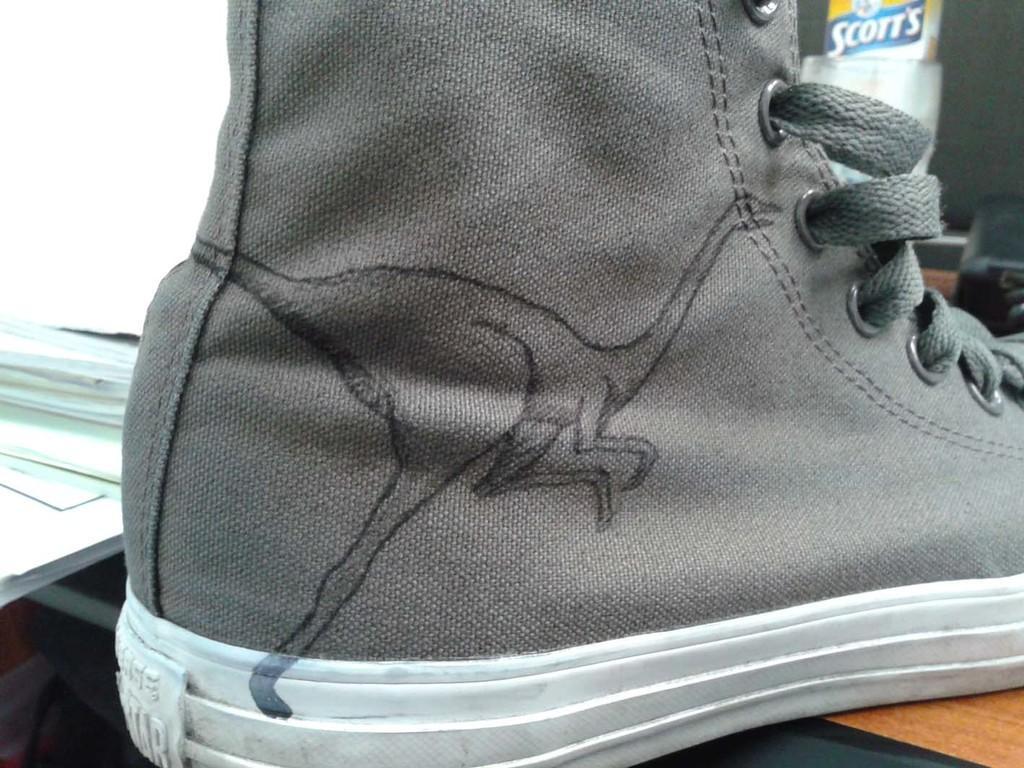Could you give a brief overview of what you see in this image? In this picture I can see a shoe placed on the wooden surface. 